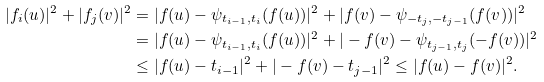Convert formula to latex. <formula><loc_0><loc_0><loc_500><loc_500>| f _ { i } ( u ) | ^ { 2 } + | f _ { j } ( v ) | ^ { 2 } & = | f ( u ) - \psi _ { t _ { i - 1 } , t _ { i } } ( f ( u ) ) | ^ { 2 } + | f ( v ) - \psi _ { - t _ { j } , - t _ { j - 1 } } ( f ( v ) ) | ^ { 2 } \\ & = | f ( u ) - \psi _ { t _ { i - 1 } , t _ { i } } ( f ( u ) ) | ^ { 2 } + | - f ( v ) - \psi _ { t _ { j - 1 } , t _ { j } } ( - f ( v ) ) | ^ { 2 } \\ & \leq | f ( u ) - t _ { i - 1 } | ^ { 2 } + | - f ( v ) - t _ { j - 1 } | ^ { 2 } \leq | f ( u ) - f ( v ) | ^ { 2 } .</formula> 